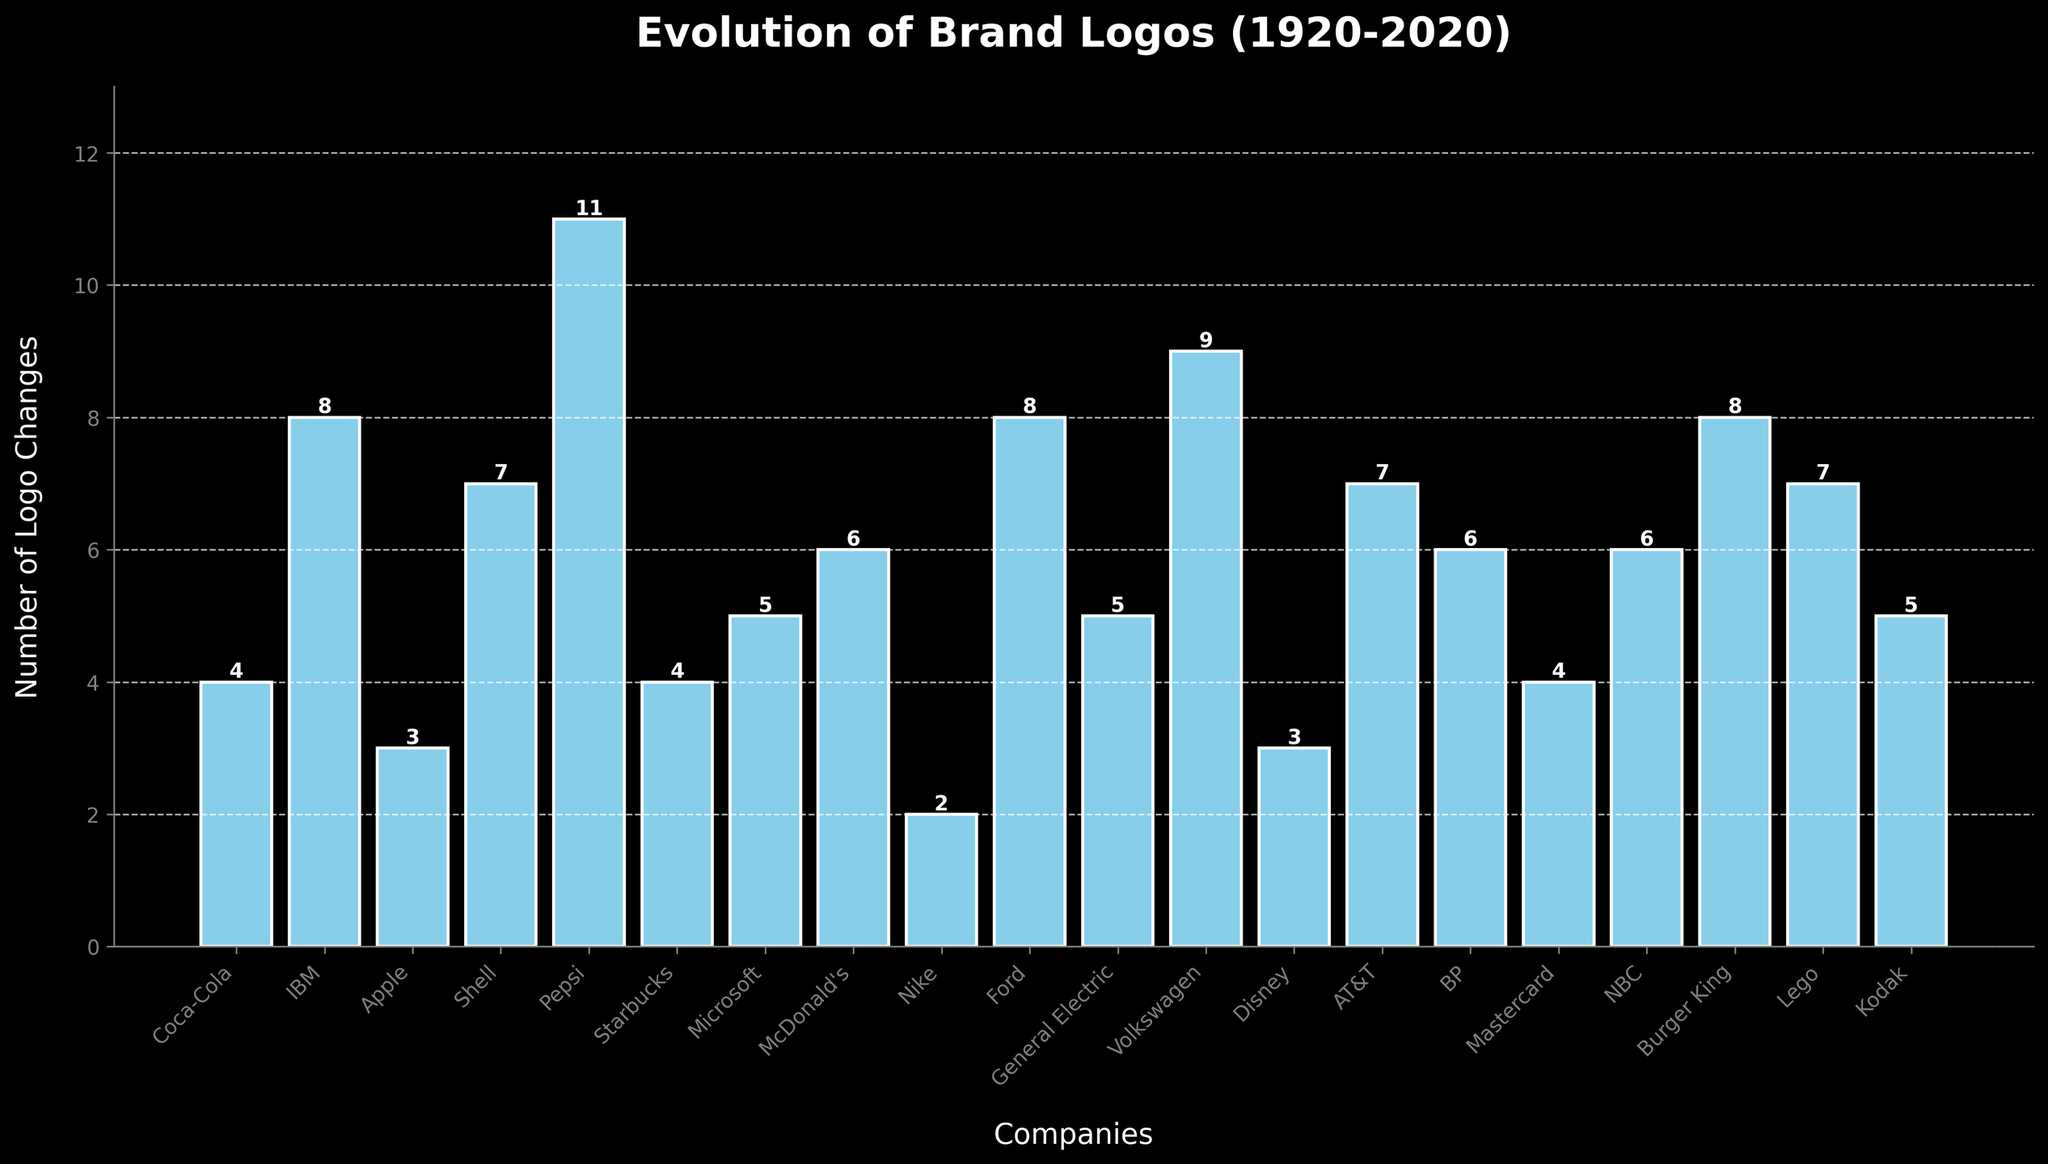What's the company with the highest number of logo changes? By analyzing the height of the bars, Pepsi has the tallest bar, which indicates it has the highest number of logo changes.
Answer: Pepsi Which two companies have the same number of logo changes, equal to 7 each? Looking at the bars labeled with the number 7, the companies are Shell, AT&T, and Lego.
Answer: Shell, AT&T, Lego How many companies have had more than 8 logo changes? By counting the bars taller than 8, we see three companies: IBM, Pepsi, and Volkswagen.
Answer: 3 What is the sum of the logo changes for Apple and Disney? Apple has 3 logo changes and Disney also has 3. Summing these values gives 3 + 3 = 6.
Answer: 6 How many more logo changes does Volkswagen have compared to Coca-Cola? Volkswagen has 9 changes and Coca-Cola has 4. The difference is 9 - 4 = 5.
Answer: 5 Which company has the fewest logo changes? By identifying the shortest bar, Nike has the fewest logo changes with 2.
Answer: Nike What is the difference in the number of logo changes between Microsoft and IBM? Microsoft has 5 logo changes and IBM has 8. The difference is 8 - 5 = 3.
Answer: 3 How many companies have had exactly 5 logo changes? Companies with 5 logo changes are Microsoft, General Electric, and Kodak. Counting these, there are 3 companies.
Answer: 3 Rank the top three companies in terms of logo changes. The companies with the highest number of logo changes are: 1st - Pepsi (11), 2nd - Volkswagen (9), and 3rd - IBM (8).
Answer: Pepsi, Volkswagen, IBM Calculate the average number of logo changes per company. Sum all logo changes: 4 + 8 + 3 + 7 + 11 + 4 + 5 + 6 + 2 + 8 + 5 + 9 + 3 + 7 + 6 + 4 + 6 + 8 + 7 + 5 = 118. There are 20 companies, so the average is 118 / 20 = 5.9.
Answer: 5.9 